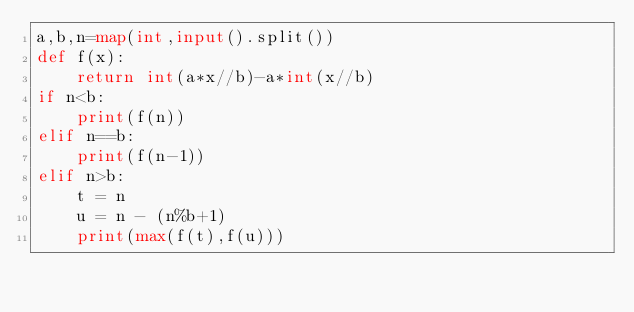Convert code to text. <code><loc_0><loc_0><loc_500><loc_500><_Python_>a,b,n=map(int,input().split())
def f(x):
    return int(a*x//b)-a*int(x//b)
if n<b:
    print(f(n))
elif n==b:
    print(f(n-1))
elif n>b:
    t = n
    u = n - (n%b+1)
    print(max(f(t),f(u)))</code> 